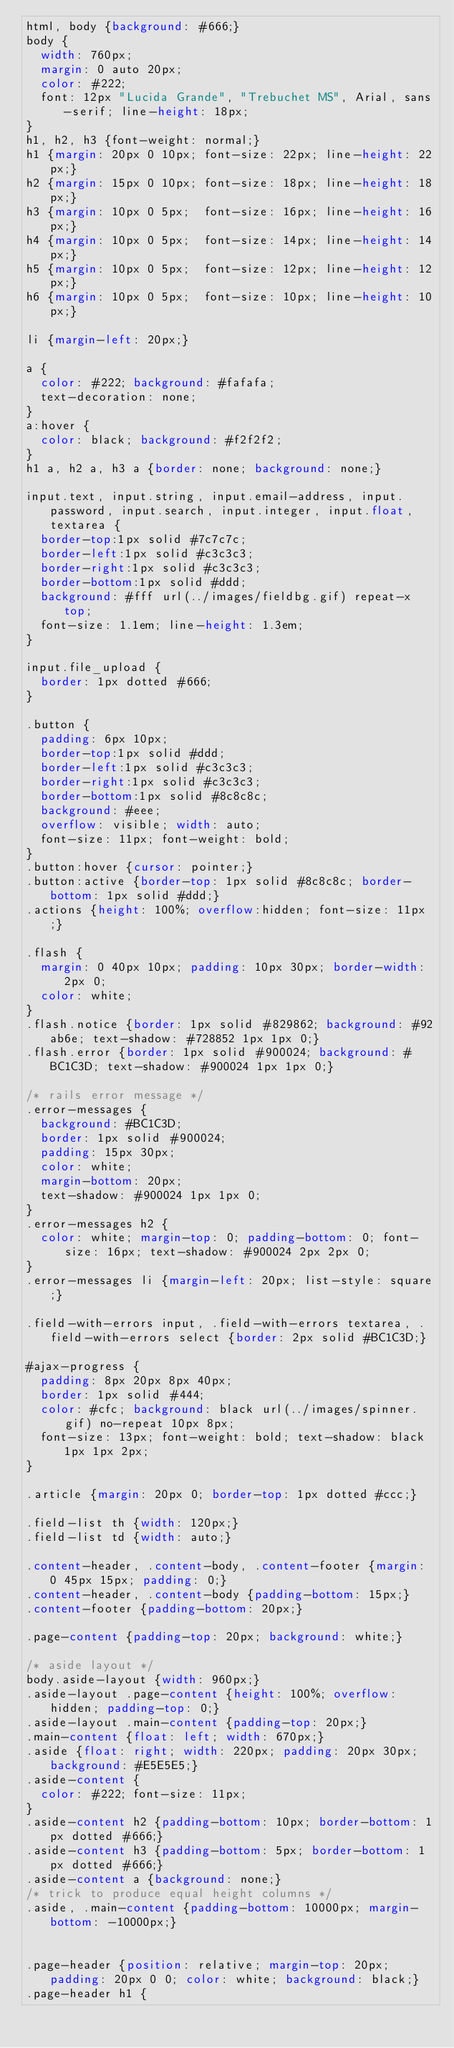Convert code to text. <code><loc_0><loc_0><loc_500><loc_500><_CSS_>html, body {background: #666;}
body {
	width: 760px;  
	margin: 0 auto 20px;
	color: #222;
	font: 12px "Lucida Grande", "Trebuchet MS", Arial, sans-serif; line-height: 18px;
}
h1, h2, h3 {font-weight: normal;}
h1 {margin: 20px 0 10px; font-size: 22px; line-height: 22px;}
h2 {margin: 15px 0 10px; font-size: 18px; line-height: 18px;}
h3 {margin: 10px 0 5px;  font-size: 16px; line-height: 16px;}
h4 {margin: 10px 0 5px;  font-size: 14px; line-height: 14px;}
h5 {margin: 10px 0 5px;  font-size: 12px; line-height: 12px;}
h6 {margin: 10px 0 5px;  font-size: 10px; line-height: 10px;}

li {margin-left: 20px;}

a {
	color: #222; background: #fafafa;
	text-decoration: none; 
}
a:hover {
	color: black; background: #f2f2f2; 
}
h1 a, h2 a, h3 a {border: none; background: none;}

input.text, input.string, input.email-address, input.password, input.search, input.integer, input.float, textarea {
	border-top:1px solid #7c7c7c;
	border-left:1px solid #c3c3c3;
	border-right:1px solid #c3c3c3;
	border-bottom:1px solid #ddd;
	background: #fff url(../images/fieldbg.gif) repeat-x top;
	font-size: 1.1em; line-height: 1.3em;
}

input.file_upload {
	border: 1px dotted #666;
}

.button {
	padding: 6px 10px;
	border-top:1px solid #ddd;
	border-left:1px solid #c3c3c3;
	border-right:1px solid #c3c3c3;
	border-bottom:1px solid #8c8c8c;
	background: #eee; 
	overflow: visible; width: auto;
	font-size: 11px; font-weight: bold;
}
.button:hover {cursor: pointer;}
.button:active {border-top: 1px solid #8c8c8c; border-bottom: 1px solid #ddd;}
.actions {height: 100%; overflow:hidden; font-size: 11px;}

.flash {
	margin: 0 40px 10px; padding: 10px 30px; border-width: 2px 0;
	color: white;
}
.flash.notice {border: 1px solid #829862; background: #92ab6e; text-shadow: #728852 1px 1px 0;}
.flash.error {border: 1px solid #900024; background: #BC1C3D; text-shadow: #900024 1px 1px 0;}

/* rails error message */
.error-messages {
	background: #BC1C3D;
	border: 1px solid #900024;
	padding: 15px 30px;
	color: white;
	margin-bottom: 20px;
	text-shadow: #900024 1px 1px 0;
}
.error-messages h2 {
	color: white; margin-top: 0; padding-bottom: 0; font-size: 16px; text-shadow: #900024 2px 2px 0;
}
.error-messages li {margin-left: 20px; list-style: square;}

.field-with-errors input, .field-with-errors textarea, .field-with-errors select {border: 2px solid #BC1C3D;}

#ajax-progress {
	padding: 8px 20px 8px 40px;
	border: 1px solid #444;
	color: #cfc; background: black url(../images/spinner.gif) no-repeat 10px 8px;
	font-size: 13px; font-weight: bold; text-shadow: black 1px 1px 2px;
}

.article {margin: 20px 0; border-top: 1px dotted #ccc;}

.field-list th {width: 120px;}
.field-list td {width: auto;}

.content-header, .content-body, .content-footer {margin: 0 45px 15px; padding: 0;}
.content-header, .content-body {padding-bottom: 15px;}
.content-footer {padding-bottom: 20px;}

.page-content {padding-top: 20px; background: white;}

/* aside layout */
body.aside-layout {width: 960px;}
.aside-layout .page-content {height: 100%; overflow: hidden; padding-top: 0;}
.aside-layout .main-content {padding-top: 20px;}
.main-content {float: left; width: 670px;}
.aside {float: right; width: 220px; padding: 20px 30px; background: #E5E5E5;}
.aside-content {
	color: #222; font-size: 11px;
}
.aside-content h2 {padding-bottom: 10px; border-bottom: 1px dotted #666;}
.aside-content h3 {padding-bottom: 5px; border-bottom: 1px dotted #666;}
.aside-content a {background: none;}
/* trick to produce equal height columns */
.aside, .main-content {padding-bottom: 10000px; margin-bottom: -10000px;}


.page-header {position: relative; margin-top: 20px; padding: 20px 0 0; color: white; background: black;}
.page-header h1 {</code> 